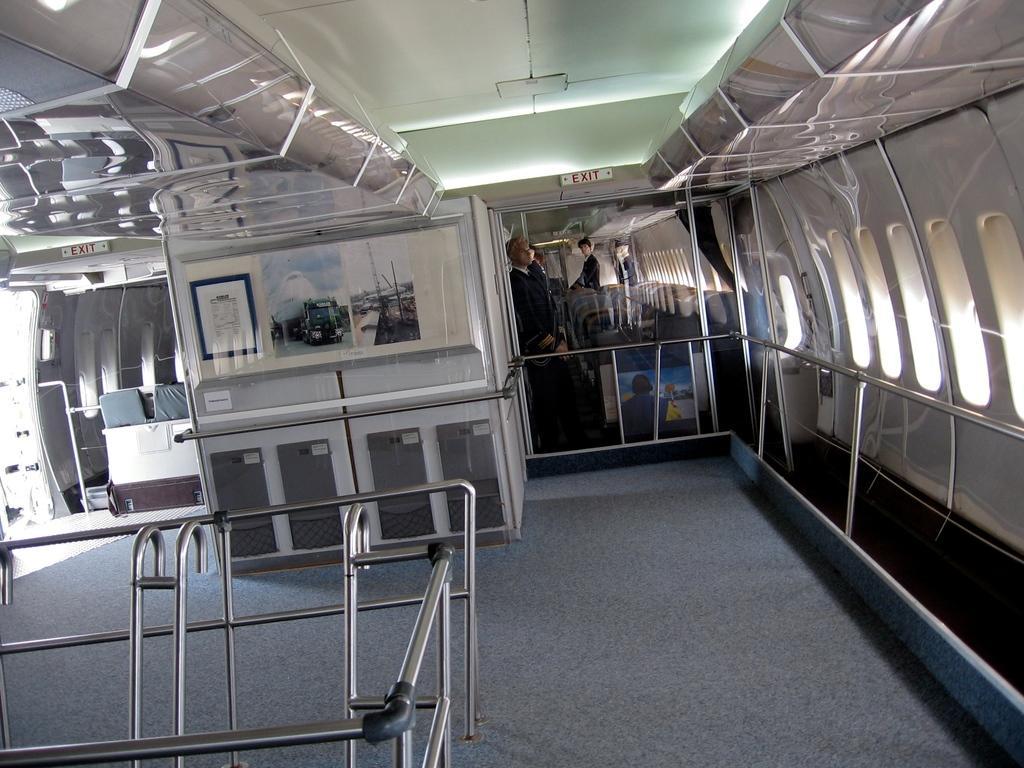Could you give a brief overview of what you see in this image? In the picture I can see few poles in the left corner and there are few photos attached to the wall and there are few persons standing beside it and there is exit written above it and there are some other objects in the background. 